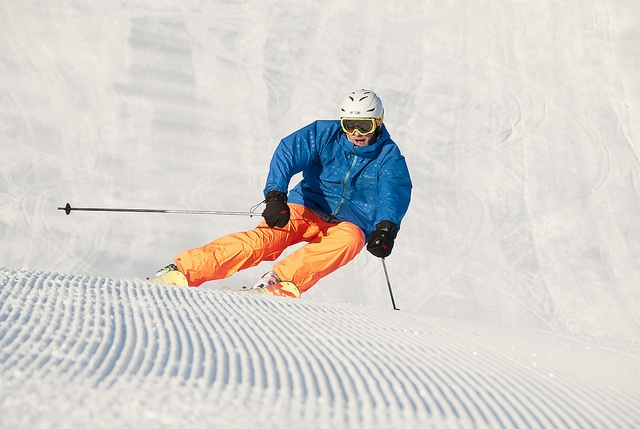Describe the objects in this image and their specific colors. I can see people in lightgray, blue, orange, black, and navy tones and skis in lightgray, khaki, salmon, and tan tones in this image. 